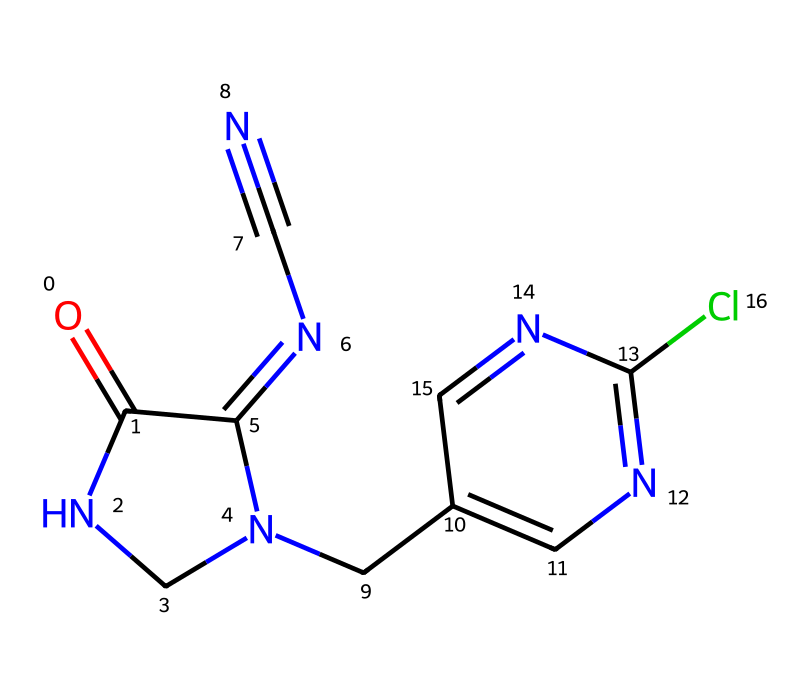What is the primary functional group present in this molecule? The molecule contains a carbonyl (C=O) group, as indicated by the "O=C" notation at the beginning of the SMILES representation. The carbonyl group is a defining feature of many chemical compounds.
Answer: carbonyl group How many nitrogen atoms are present in the structure? By analyzing the SMILES, we can count the nitrogen atoms highlighted by 'N' within the chemical structure. There are a total of 5 nitrogen atoms in this structure.
Answer: 5 What is the molecular formula derived from this SMILES representation? To derive the molecular formula, count the carbons (C), hydrogens (H), nitrogens (N), and chlorines (Cl) indicated in the SMILES. The counts result in a molecular formula of C8H8ClN5O.
Answer: C8H8ClN5O Which part of this chemical structure contributes to its role as a pesticide? The presence of the nitro group and the complex nitrogen-containing ring structure are characteristics typical of neonicotinoids, which target the nervous system of pests.
Answer: nitrogen-containing ring Is this chemical likely to be water-soluble? The presence of a polar functional group, like the carbonyl and nitrogen atoms, suggests potential water solubility. However, the overall structure's hydrophobic characteristics may limit it. A detailed solubility test would be needed for confirmation.
Answer: likely What is the expected target species of this pesticide based on its chemical structure? Neonicotinoids are primarily designed to target harmful insects by interfering with their nervous system. The structure's similarity to nicotine suggests it would affect insect species, particularly pests like aphids.
Answer: harmful insects How many rings are there in the chemical structure? Examining the SMILES, we identify two cyclic portions: the imidazolidine and the second ring with the chlorine which indicates a fused system. Summing these gives a total of 2 rings in the structure.
Answer: 2 